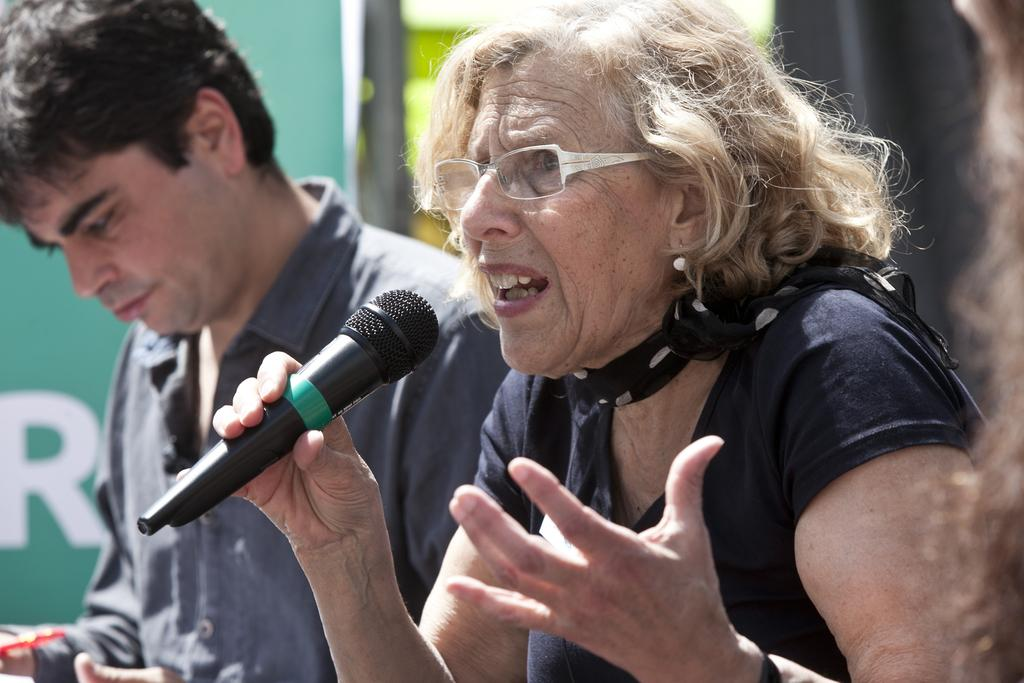Who is the main subject in the image? There is a woman in the image. What is the woman holding in her right hand? The woman is holding a microphone in her right hand. What is the woman doing in the image? The woman is speaking. Can you describe the position of the man in the image? The man is on the left side of the image. What type of land can be seen in the aftermath of the cattle stampede in the image? There is no land, cattle, or stampede present in the image. 